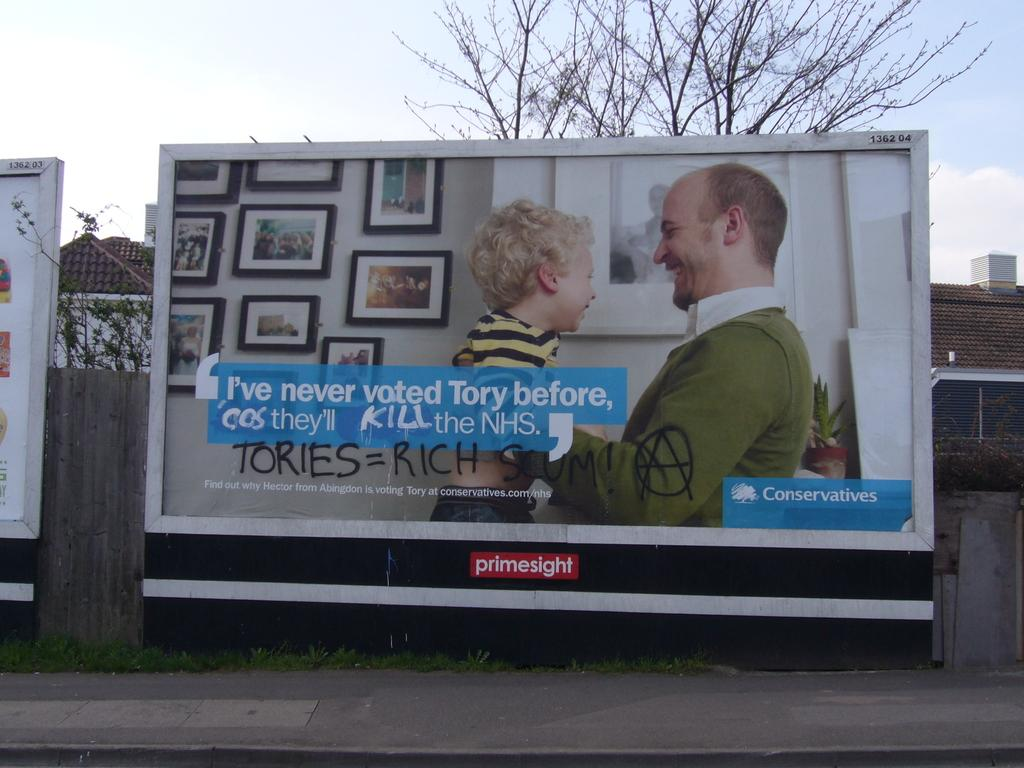<image>
Summarize the visual content of the image. Banner saying " I've never voted Tory before, cos they"ll kill the NHS. 